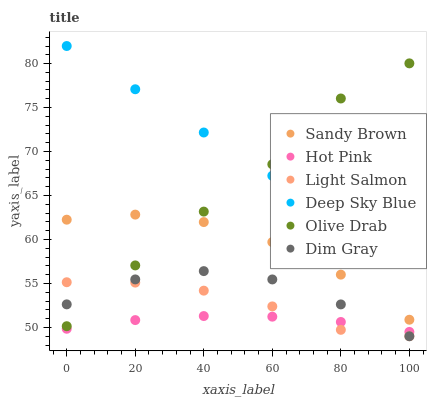Does Hot Pink have the minimum area under the curve?
Answer yes or no. Yes. Does Deep Sky Blue have the maximum area under the curve?
Answer yes or no. Yes. Does Dim Gray have the minimum area under the curve?
Answer yes or no. No. Does Dim Gray have the maximum area under the curve?
Answer yes or no. No. Is Deep Sky Blue the smoothest?
Answer yes or no. Yes. Is Olive Drab the roughest?
Answer yes or no. Yes. Is Dim Gray the smoothest?
Answer yes or no. No. Is Dim Gray the roughest?
Answer yes or no. No. Does Light Salmon have the lowest value?
Answer yes or no. Yes. Does Hot Pink have the lowest value?
Answer yes or no. No. Does Deep Sky Blue have the highest value?
Answer yes or no. Yes. Does Dim Gray have the highest value?
Answer yes or no. No. Is Sandy Brown less than Deep Sky Blue?
Answer yes or no. Yes. Is Sandy Brown greater than Dim Gray?
Answer yes or no. Yes. Does Light Salmon intersect Hot Pink?
Answer yes or no. Yes. Is Light Salmon less than Hot Pink?
Answer yes or no. No. Is Light Salmon greater than Hot Pink?
Answer yes or no. No. Does Sandy Brown intersect Deep Sky Blue?
Answer yes or no. No. 